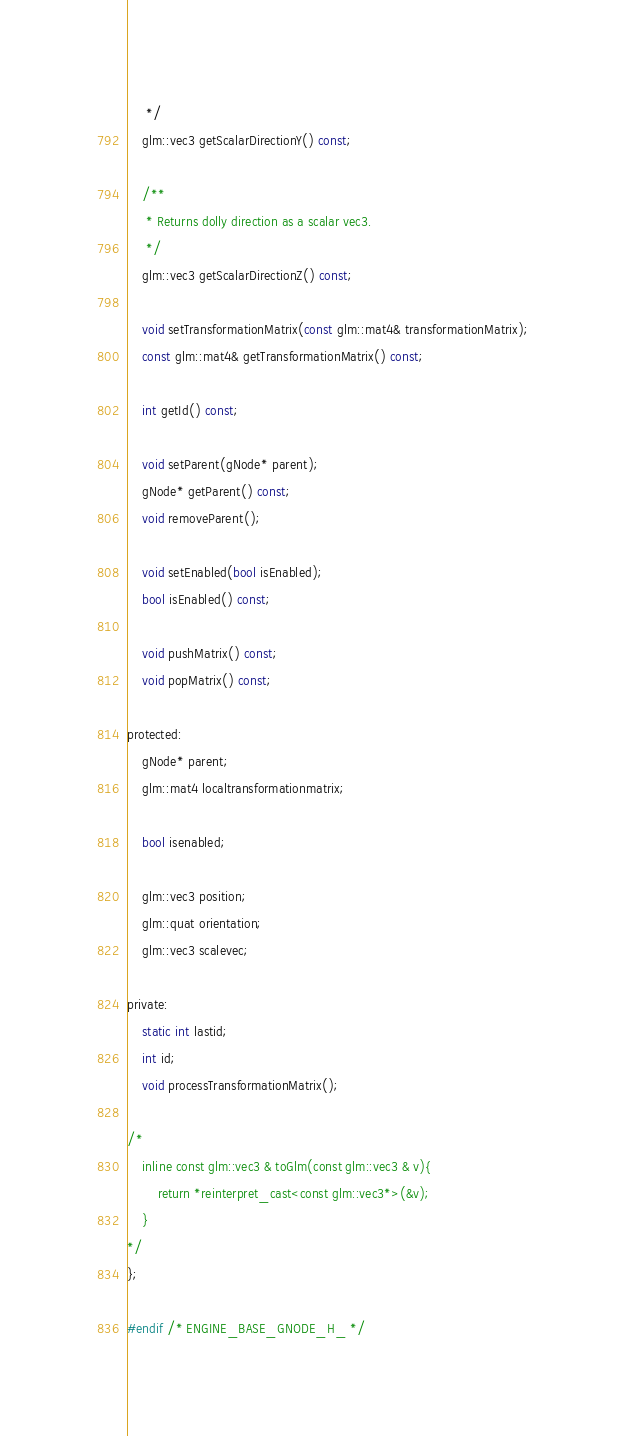<code> <loc_0><loc_0><loc_500><loc_500><_C_>	 */
	glm::vec3 getScalarDirectionY() const;

	/**
	 * Returns dolly direction as a scalar vec3.
	 */
	glm::vec3 getScalarDirectionZ() const;

	void setTransformationMatrix(const glm::mat4& transformationMatrix);
	const glm::mat4& getTransformationMatrix() const;

	int getId() const;

	void setParent(gNode* parent);
	gNode* getParent() const;
	void removeParent();

	void setEnabled(bool isEnabled);
	bool isEnabled() const;

	void pushMatrix() const;
	void popMatrix() const;

protected:
	gNode* parent;
	glm::mat4 localtransformationmatrix;

	bool isenabled;

	glm::vec3 position;
	glm::quat orientation;
	glm::vec3 scalevec;

private:
	static int lastid;
	int id;
	void processTransformationMatrix();

/*
	inline const glm::vec3 & toGlm(const glm::vec3 & v){
		return *reinterpret_cast<const glm::vec3*>(&v);
	}
*/
};

#endif /* ENGINE_BASE_GNODE_H_ */
</code> 